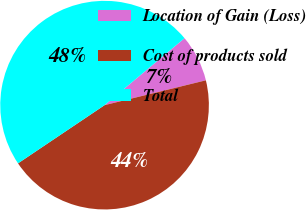Convert chart to OTSL. <chart><loc_0><loc_0><loc_500><loc_500><pie_chart><fcel>Location of Gain (Loss)<fcel>Cost of products sold<fcel>Total<nl><fcel>7.27%<fcel>44.41%<fcel>48.33%<nl></chart> 